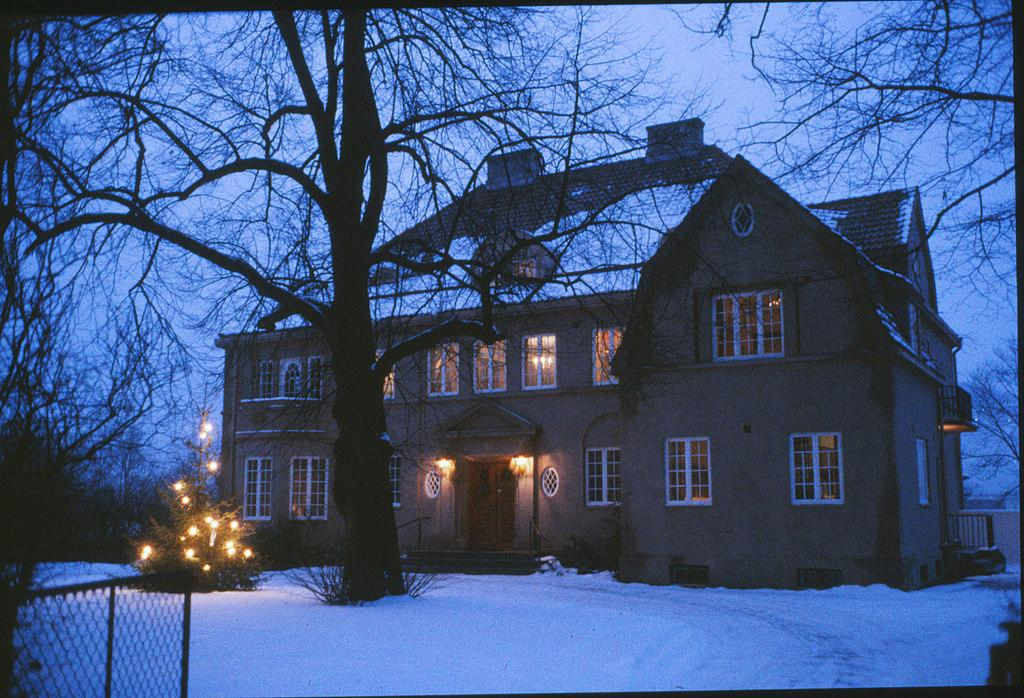What type of material is present in the image? There is mesh in the image. What is the weather condition in the image? There is snow in the image. What type of vegetation can be seen in the image? There are plants and trees in the image. What type of artificial lighting is present in the image? There are lights in the image. What type of structure is present in the image? There is a building in the image. What architectural feature is present in the building? There are windows in the image. What is visible in the background of the image? The sky is visible in the background of the image. Can you tell me how many keys are hanging from the plants in the image? There are no keys present in the image; it features mesh, snow, plants, trees, lights, a building, windows, and a visible sky. What type of creature is using its tongue to interact with the mesh in the image? There is no creature present in the image that is interacting with the mesh or using its tongue. 